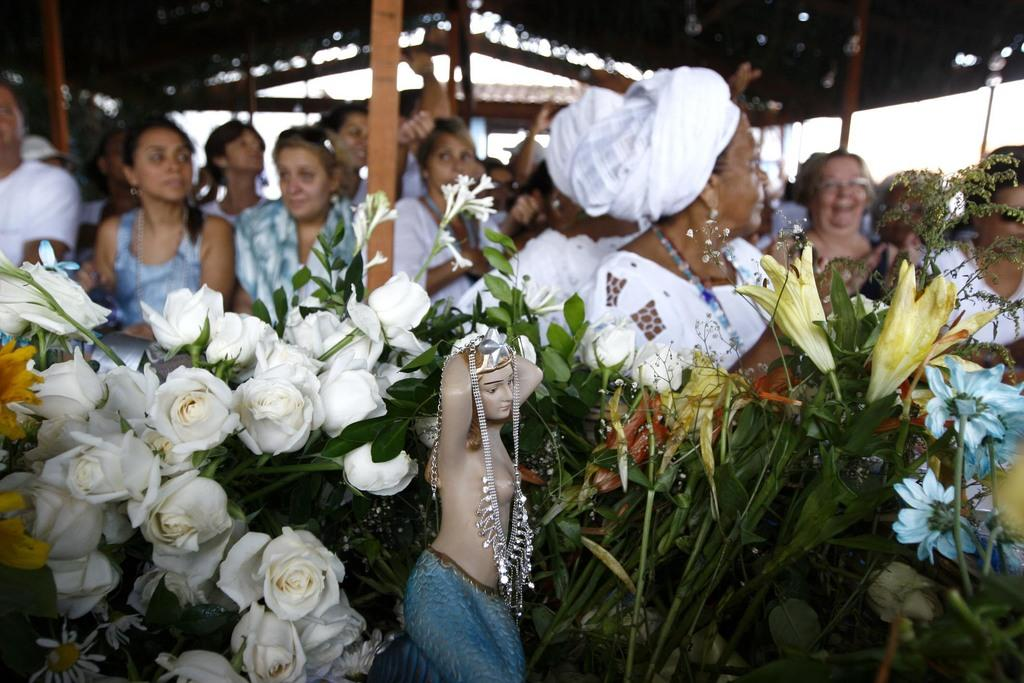What is the main subject in the front of the image? There is a statue in the front of the image. What type of plants can be seen in the image? There are flowers in the image. What can be observed in the background of the image? There are persons, poles, and tents in the background of the image. How many trees are present in the image? There are no trees mentioned or visible in the image. 